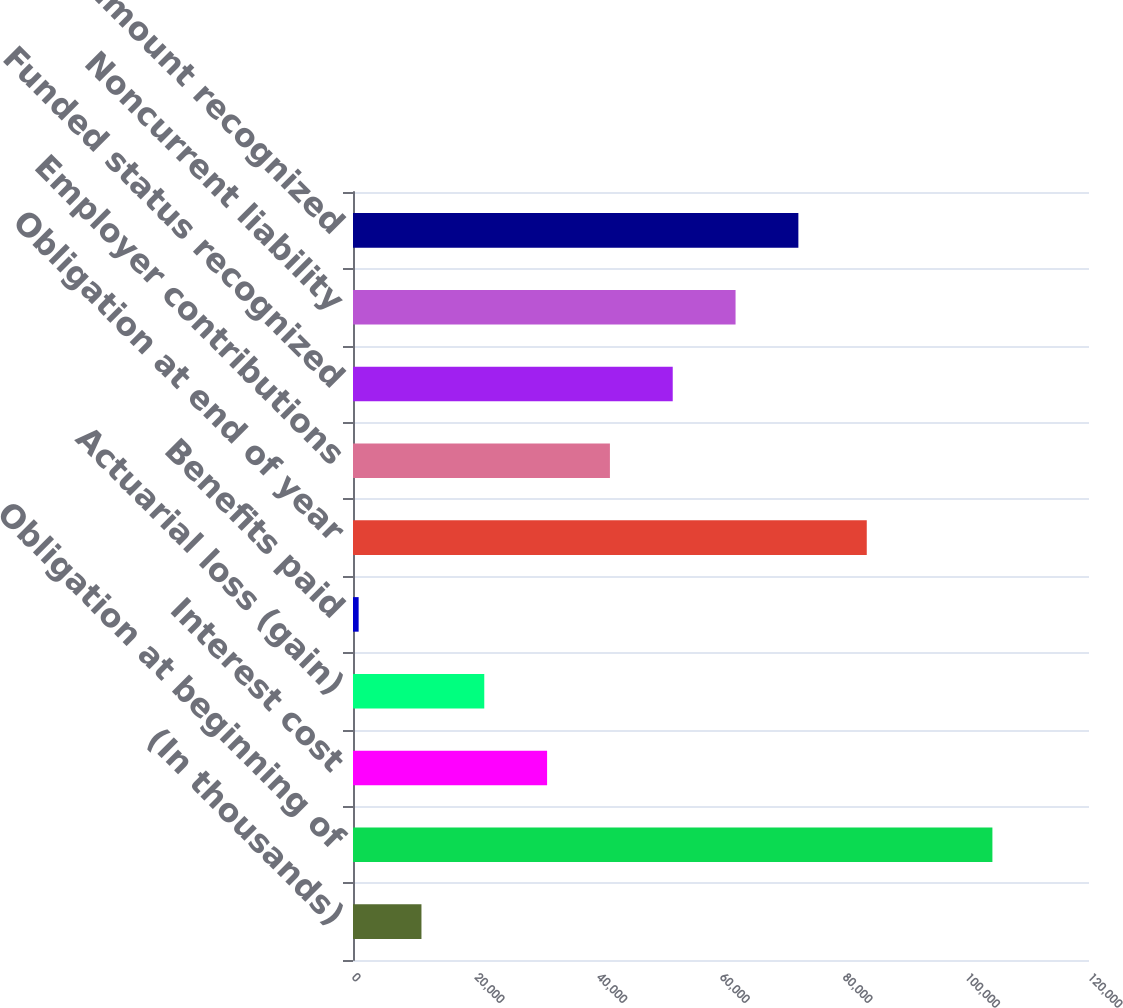Convert chart to OTSL. <chart><loc_0><loc_0><loc_500><loc_500><bar_chart><fcel>(In thousands)<fcel>Obligation at beginning of<fcel>Interest cost<fcel>Actuarial loss (gain)<fcel>Benefits paid<fcel>Obligation at end of year<fcel>Employer contributions<fcel>Funded status recognized<fcel>Noncurrent liability<fcel>Net amount recognized<nl><fcel>11161.3<fcel>104251<fcel>31645.9<fcel>21403.6<fcel>919<fcel>83766<fcel>41888.2<fcel>52130.5<fcel>62372.8<fcel>72615.1<nl></chart> 